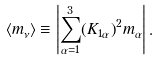<formula> <loc_0><loc_0><loc_500><loc_500>\left < m _ { \nu } \right > \equiv \left | { \sum _ { \alpha = 1 } ^ { 3 } } { \left ( K _ { 1 \alpha } \right ) } ^ { 2 } m _ { \alpha } \right | .</formula> 